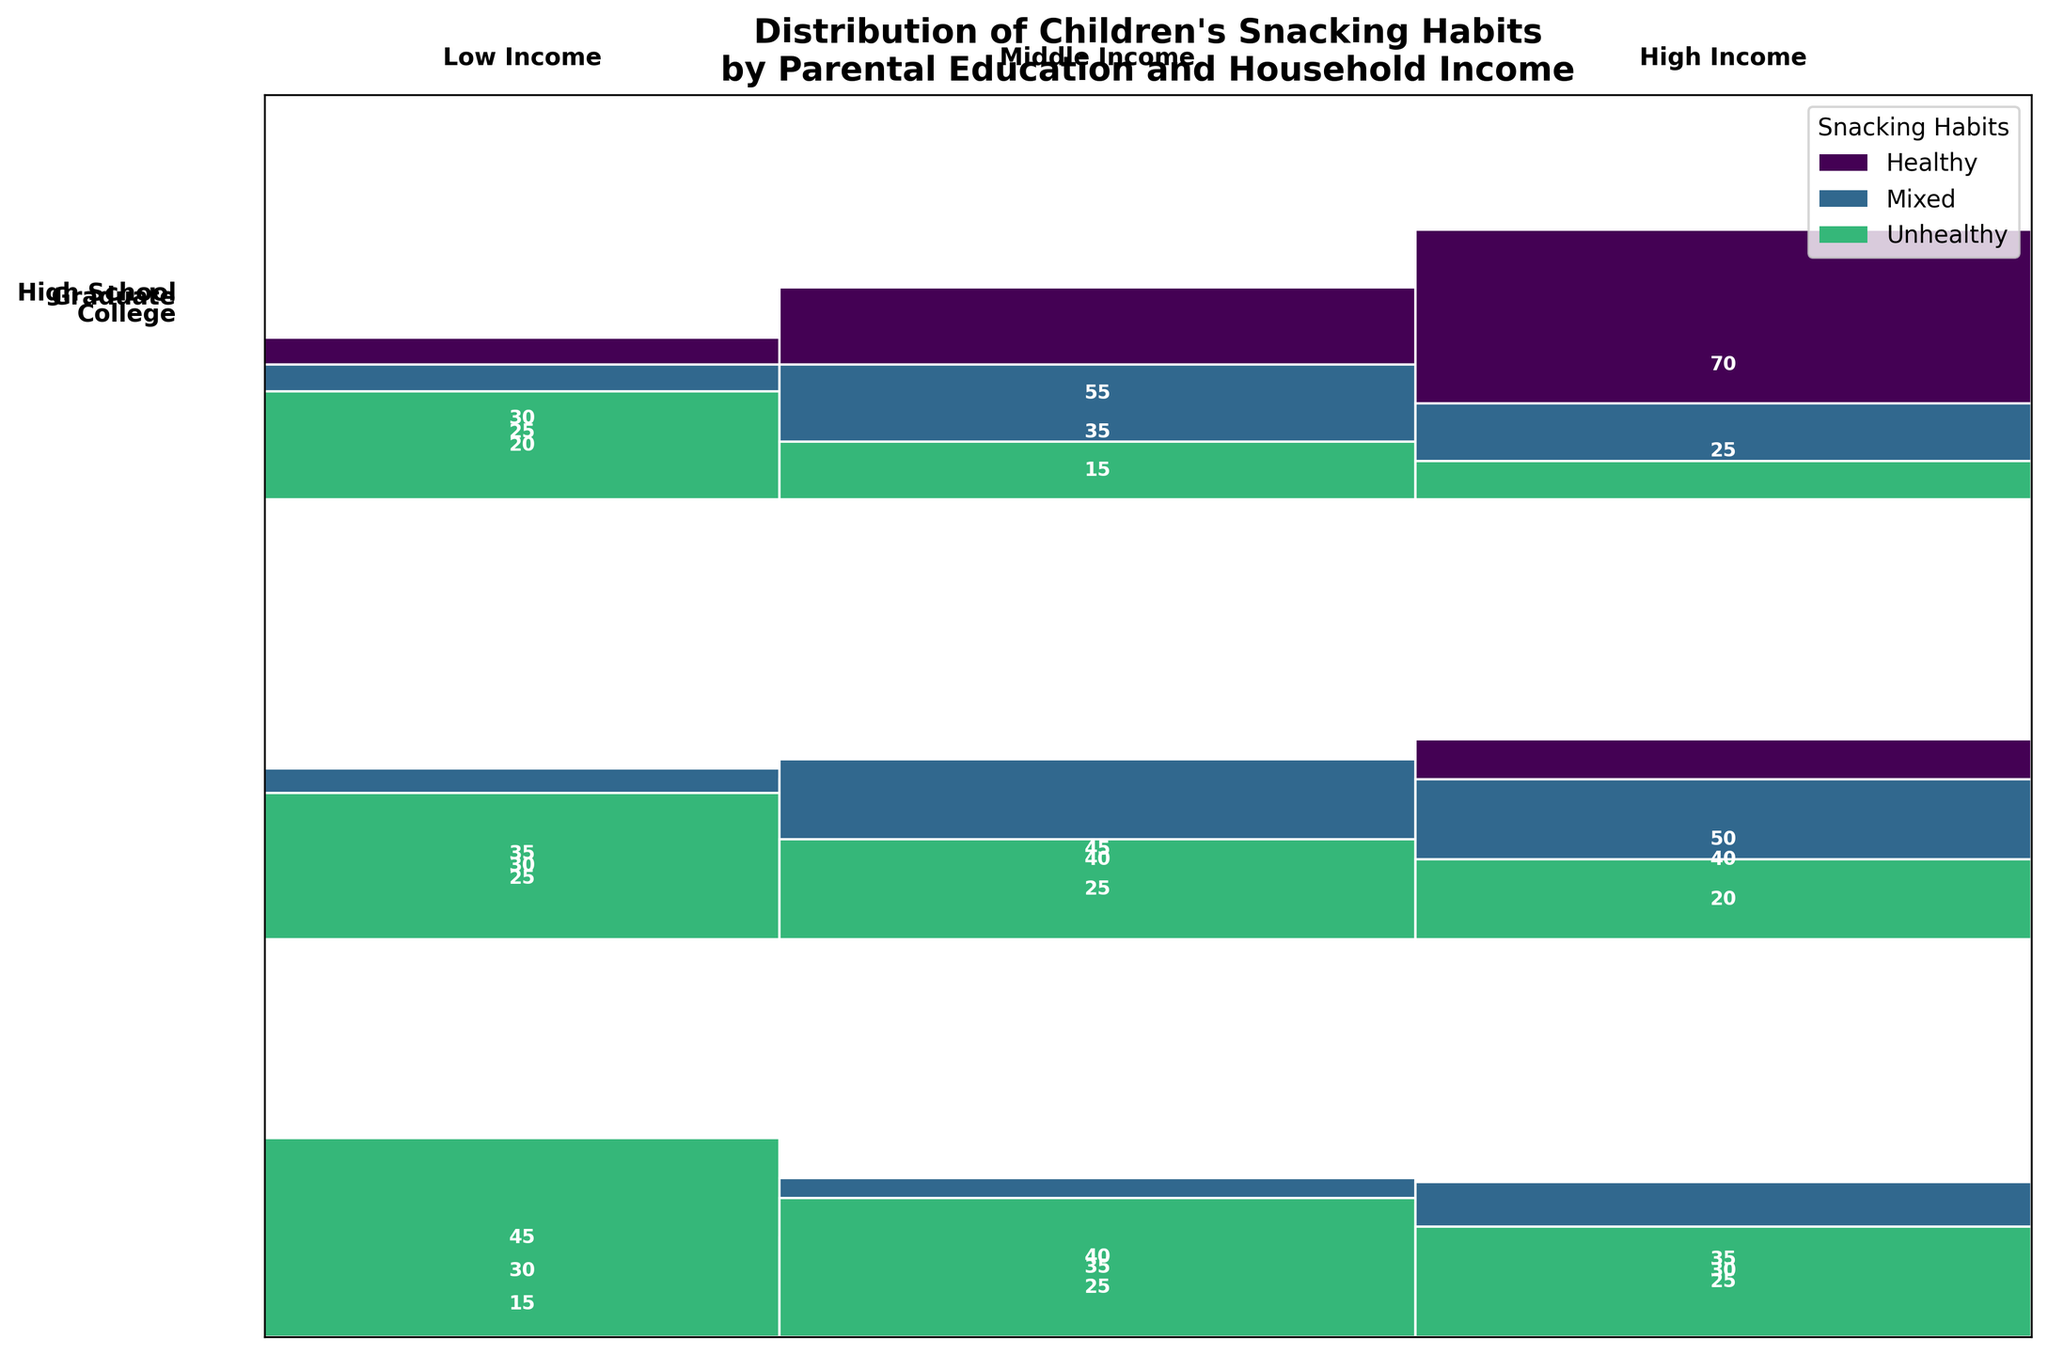What is the title of the figure? The title is typically placed at the top of the figure and provides a concise summary. In this case, the title gives context about the distribution of children's snacking habits based on parental education levels and household income.
Answer: Distribution of Children's Snacking Habits by Parental Education and Household Income Which parental education level has the highest proportion of children with healthy snacking habits? Look at the segments representing 'Healthy' snacking habits for each parental education level and observe their heights. The tallest segment corresponds to the parental education level with the highest proportion of healthy snacking habits.
Answer: Graduate Among high school-educated parents, which household income level has the largest number of children with unhealthy snacking habits? Examine the 'Unhealthy' snacking habits segments for high school-educated parents across different household income levels. The segment with the largest height represents the income level with the highest count.
Answer: Low Income How does the proportion of healthy snacking habits compare between children of middle-income college-educated parents and high-income graduate-educated parents? Compare the height of the 'Healthy' segments for middle-income college-educated parents and high-income graduate-educated parents. The graduate-educated parents at high income have a taller segment.
Answer: Higher for high-income graduate-educated parents What is the total number of children from households with low income and high school education? Sum up the counts for all snacking habit categories (Healthy, Mixed, Unhealthy) for children from low-income, high school-educated households. This involves summing 15 (Healthy) + 30 (Mixed) + 45 (Unhealthy).
Answer: 90 Which snacking habit category is the least common among children of high-income parents with high school education? Identify the 'Healthy', 'Mixed', and 'Unhealthy' segments for high school-educated parents with high income. The segment with the smallest height represents the least common category.
Answer: Unhealthy Do graduate-educated parents with middle income have a higher count of children with mixed snacking habits compared to college-educated parents with middle income? Compare the 'Mixed' snacking habits segments. Sum the counts for each group: 35 for graduates vs. 45 for college, comparing these values directly.
Answer: No Are there more children with unhealthy snacking habits in low-income or middle-income households with college-educated parents? Compare the heights of the 'Unhealthy' segments for low-income and middle-income households among college-educated parents. The taller segment indicates the group with more children.
Answer: Low Income Which snacking habit is most prevalent among children of parents with a graduate education but low household income? Look at the segments for low-income households among graduate-educated parents. The tallest segment indicates the most prevalent snacking habit.
Answer: Healthy In households with high-income and college-educated parents, is the number of children with mixed snacking habits greater than that with unhealthy snacking habits? Compare the counts of 'Mixed' and 'Unhealthy' segments for high-income, college-educated households. Check if 40 (Mixed) is greater than 20 (Unhealthy).
Answer: Yes 